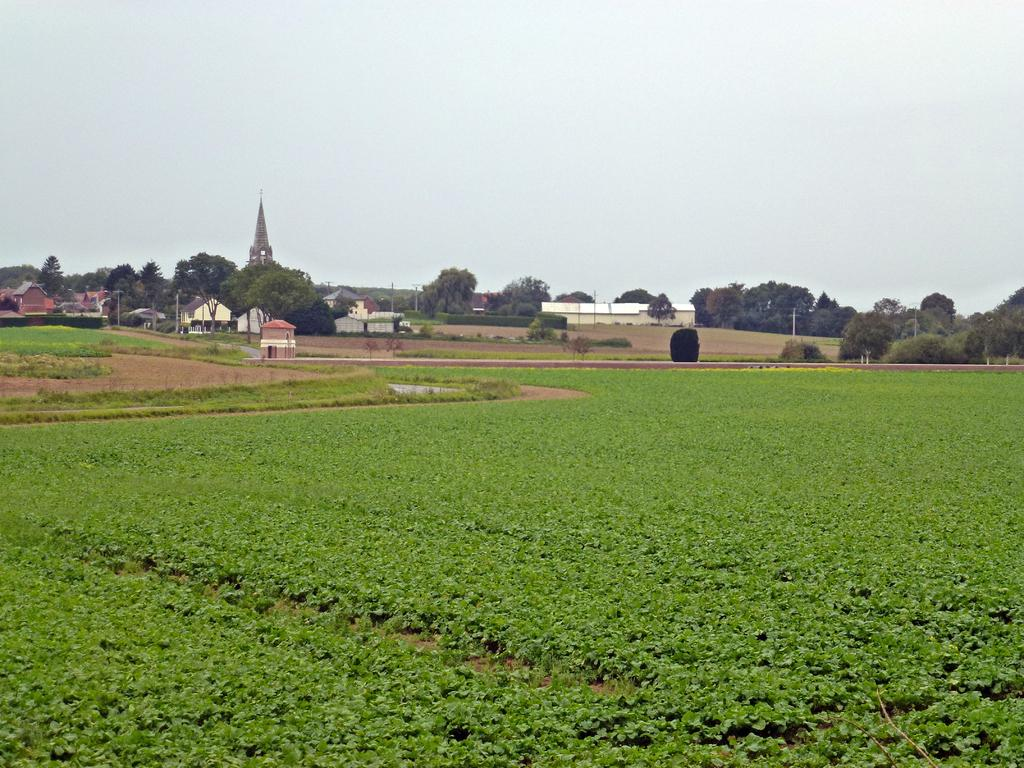What type of landscape is at the bottom of the image? There is a field at the bottom of the image. What can be seen in the middle of the image? Trees and buildings are visible in the middle of the image. What is visible at the top of the image? The sky is visible at the top of the image. What type of egg is being used to construct the buildings in the image? There is no egg present in the image, and the buildings are not made of egg. What type of steel is visible in the image? There is no steel present in the image; the buildings are not made of steel. 